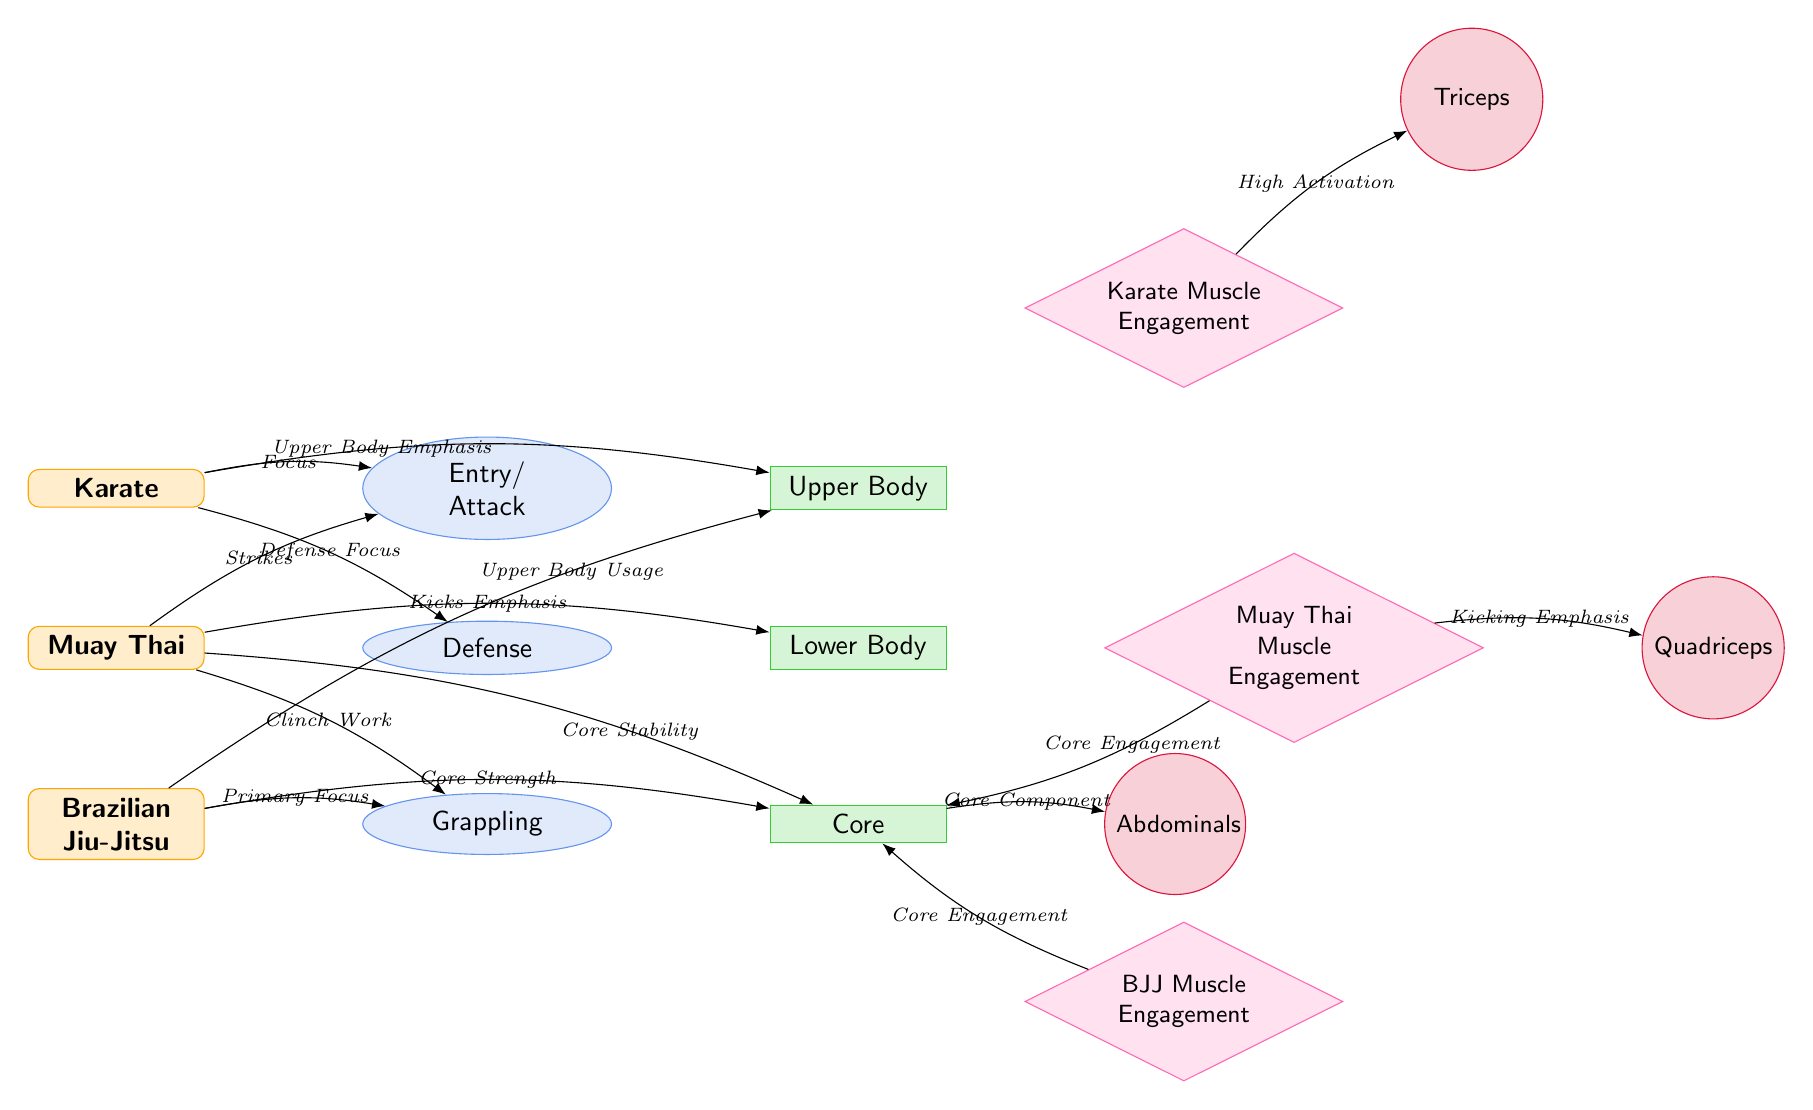What martial art is focused on Entry/Attack? The diagram shows that Karate is associated with the technique of Entry/Attack, indicated by the directed edge connecting Karate to Entry/Attack.
Answer: Karate How many techniques are displayed in the diagram? By counting the techniques listed next to each martial art, we see three techniques mapped out: Entry/Attack, Defense, and Grappling.
Answer: 3 Which muscle group is primarily emphasized in Muay Thai? The diagram shows that Muay Thai emphasizes the Lower Body, which connects from the Defense technique node.
Answer: Lower Body What does the diagram indicate about BJJ's focus regarding technique? BJJ is primarily focused on the Grappling technique, as indicated by the direct edge connecting BJJ to Grappling.
Answer: Grappling Which muscle is highly activated in Karate? The diagram indicates that the Triceps muscle has high activation associated with Karate, as mentioned in the insight connected to Karate Muscle Engagement.
Answer: Triceps What is the muscle group involved in Kicking Emphasis for Muay Thai? The diagram illustrates that the muscle group involved in Kicking Emphasis for Muay Thai is the Quadriceps, linked directly from Muay Thai Muscle Engagement to Quadriceps.
Answer: Quadriceps Describe the relationship between Muay Thai and Core Stability. The edge labeled "Core Stability" connects Muay Thai to the Core muscle group, indicating that Muay Thai incorporates core strength in addition to its primary focus on strikes and clinch work.
Answer: Core Stability Identify the muscle group that is significantly utilized in Brazilian Jiu-Jitsu. The Core muscle group is indicated to be significant in Brazilian Jiu-Jitsu, as it connects through edges detailing the focus on grappling and core strength.
Answer: Core What martial art shows Upper Body Usage as a key element? The diagram identifies that Brazilian Jiu-Jitsu (BJJ) is associated with Upper Body Usage, which is marked by an edge leading to the Upper Body muscle group.
Answer: Brazilian Jiu-Jitsu 